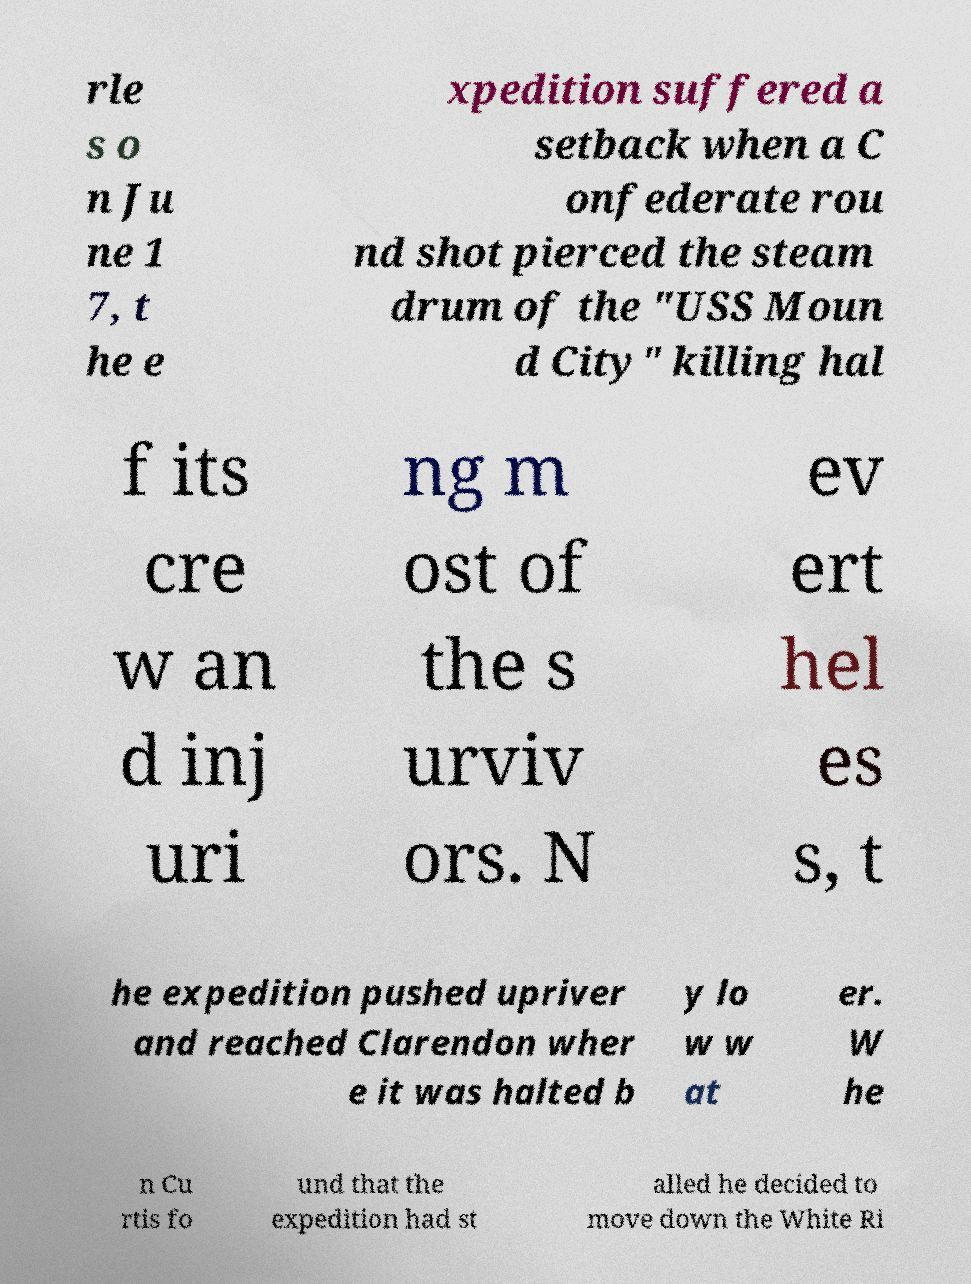Could you extract and type out the text from this image? rle s o n Ju ne 1 7, t he e xpedition suffered a setback when a C onfederate rou nd shot pierced the steam drum of the "USS Moun d City" killing hal f its cre w an d inj uri ng m ost of the s urviv ors. N ev ert hel es s, t he expedition pushed upriver and reached Clarendon wher e it was halted b y lo w w at er. W he n Cu rtis fo und that the expedition had st alled he decided to move down the White Ri 